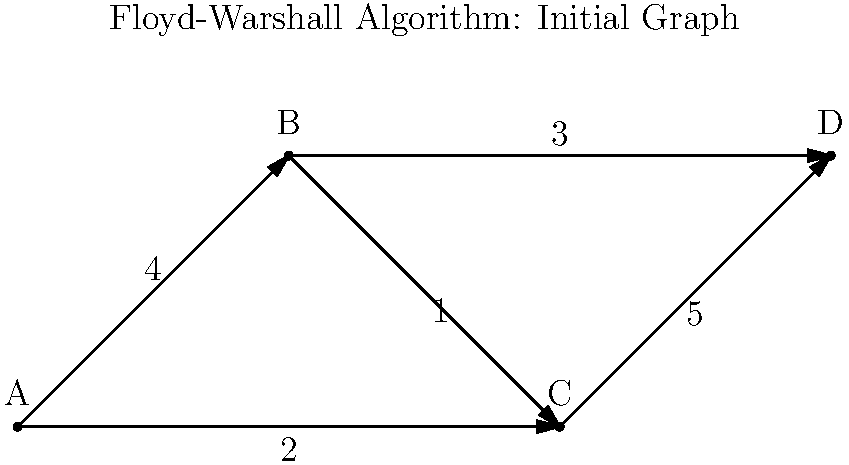Given the weighted directed graph shown above, what is the shortest path length from vertex A to vertex D after applying the Floyd-Warshall algorithm? To solve this problem using the Floyd-Warshall algorithm, we follow these steps:

1) Initialize the distance matrix $D$ with the given edge weights, and $\infty$ for non-adjacent vertices:

   $$D^{(0)} = \begin{bmatrix}
   0 & 4 & 2 & \infty \\
   \infty & 0 & 1 & 3 \\
   \infty & \infty & 0 & 5 \\
   \infty & \infty & \infty & 0
   \end{bmatrix}$$

2) Apply the Floyd-Warshall algorithm:
   For $k = 1$ to $n$ (where $n$ is the number of vertices):
      For $i = 1$ to $n$:
         For $j = 1$ to $n$:
            $D_{ij}^{(k)} = \min(D_{ij}^{(k-1)}, D_{ik}^{(k-1)} + D_{kj}^{(k-1)})$

3) After the first iteration ($k=1$, considering vertex A as an intermediate):
   No changes, as A is the starting vertex.

4) After the second iteration ($k=2$, considering vertex B):
   $D_{AD}^{(2)} = \min(D_{AD}^{(1)}, D_{AB}^{(1)} + D_{BD}^{(1)}) = \min(\infty, 4 + 3) = 7$

5) After the third iteration ($k=3$, considering vertex C):
   $D_{AD}^{(3)} = \min(D_{AD}^{(2)}, D_{AC}^{(2)} + D_{CD}^{(2)}) = \min(7, 2 + 5) = 7$

6) The final iteration ($k=4$, considering vertex D) doesn't change the result.

Therefore, the shortest path length from A to D is 7.
Answer: 7 